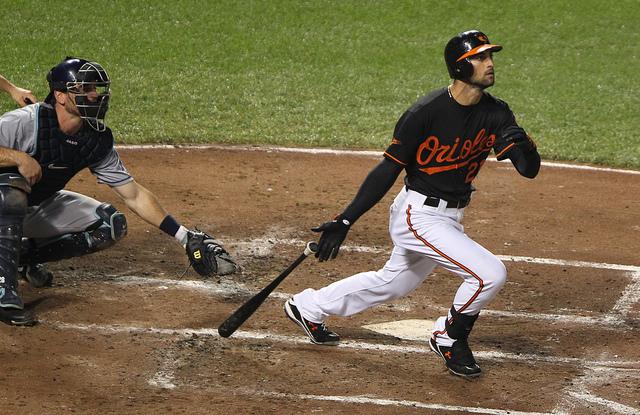Did the batter hit the ball?
Short answer required. Yes. What team does this man play for?
Write a very short answer. Orioles. Is he still holding the bat?
Keep it brief. No. How many hands is on the bat?
Quick response, please. 0. Are these professional players?
Quick response, please. Yes. 